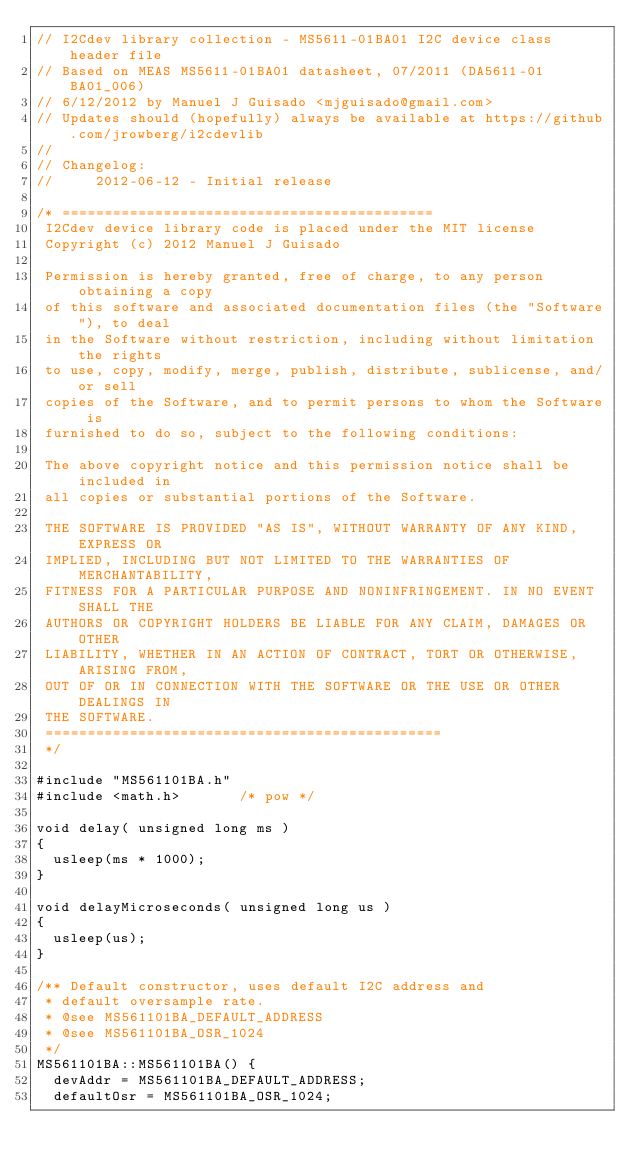Convert code to text. <code><loc_0><loc_0><loc_500><loc_500><_C++_>// I2Cdev library collection - MS5611-01BA01 I2C device class header file
// Based on MEAS MS5611-01BA01 datasheet, 07/2011 (DA5611-01BA01_006)
// 6/12/2012 by Manuel J Guisado <mjguisado@gmail.com>
// Updates should (hopefully) always be available at https://github.com/jrowberg/i2cdevlib
//
// Changelog:
//     2012-06-12 - Initial release

/* ============================================
 I2Cdev device library code is placed under the MIT license
 Copyright (c) 2012 Manuel J Guisado

 Permission is hereby granted, free of charge, to any person obtaining a copy
 of this software and associated documentation files (the "Software"), to deal
 in the Software without restriction, including without limitation the rights
 to use, copy, modify, merge, publish, distribute, sublicense, and/or sell
 copies of the Software, and to permit persons to whom the Software is
 furnished to do so, subject to the following conditions:

 The above copyright notice and this permission notice shall be included in
 all copies or substantial portions of the Software.

 THE SOFTWARE IS PROVIDED "AS IS", WITHOUT WARRANTY OF ANY KIND, EXPRESS OR
 IMPLIED, INCLUDING BUT NOT LIMITED TO THE WARRANTIES OF MERCHANTABILITY,
 FITNESS FOR A PARTICULAR PURPOSE AND NONINFRINGEMENT. IN NO EVENT SHALL THE
 AUTHORS OR COPYRIGHT HOLDERS BE LIABLE FOR ANY CLAIM, DAMAGES OR OTHER
 LIABILITY, WHETHER IN AN ACTION OF CONTRACT, TORT OR OTHERWISE, ARISING FROM,
 OUT OF OR IN CONNECTION WITH THE SOFTWARE OR THE USE OR OTHER DEALINGS IN
 THE SOFTWARE.
 ===============================================
 */

#include "MS561101BA.h"
#include <math.h>       /* pow */

void delay( unsigned long ms )
{
	usleep(ms * 1000);
} 

void delayMicroseconds( unsigned long us )
{
	usleep(us);
}

/** Default constructor, uses default I2C address and
 * default oversample rate.
 * @see MS561101BA_DEFAULT_ADDRESS
 * @see MS561101BA_OSR_1024
 */
MS561101BA::MS561101BA() {
	devAddr = MS561101BA_DEFAULT_ADDRESS;
	defaultOsr = MS561101BA_OSR_1024;</code> 